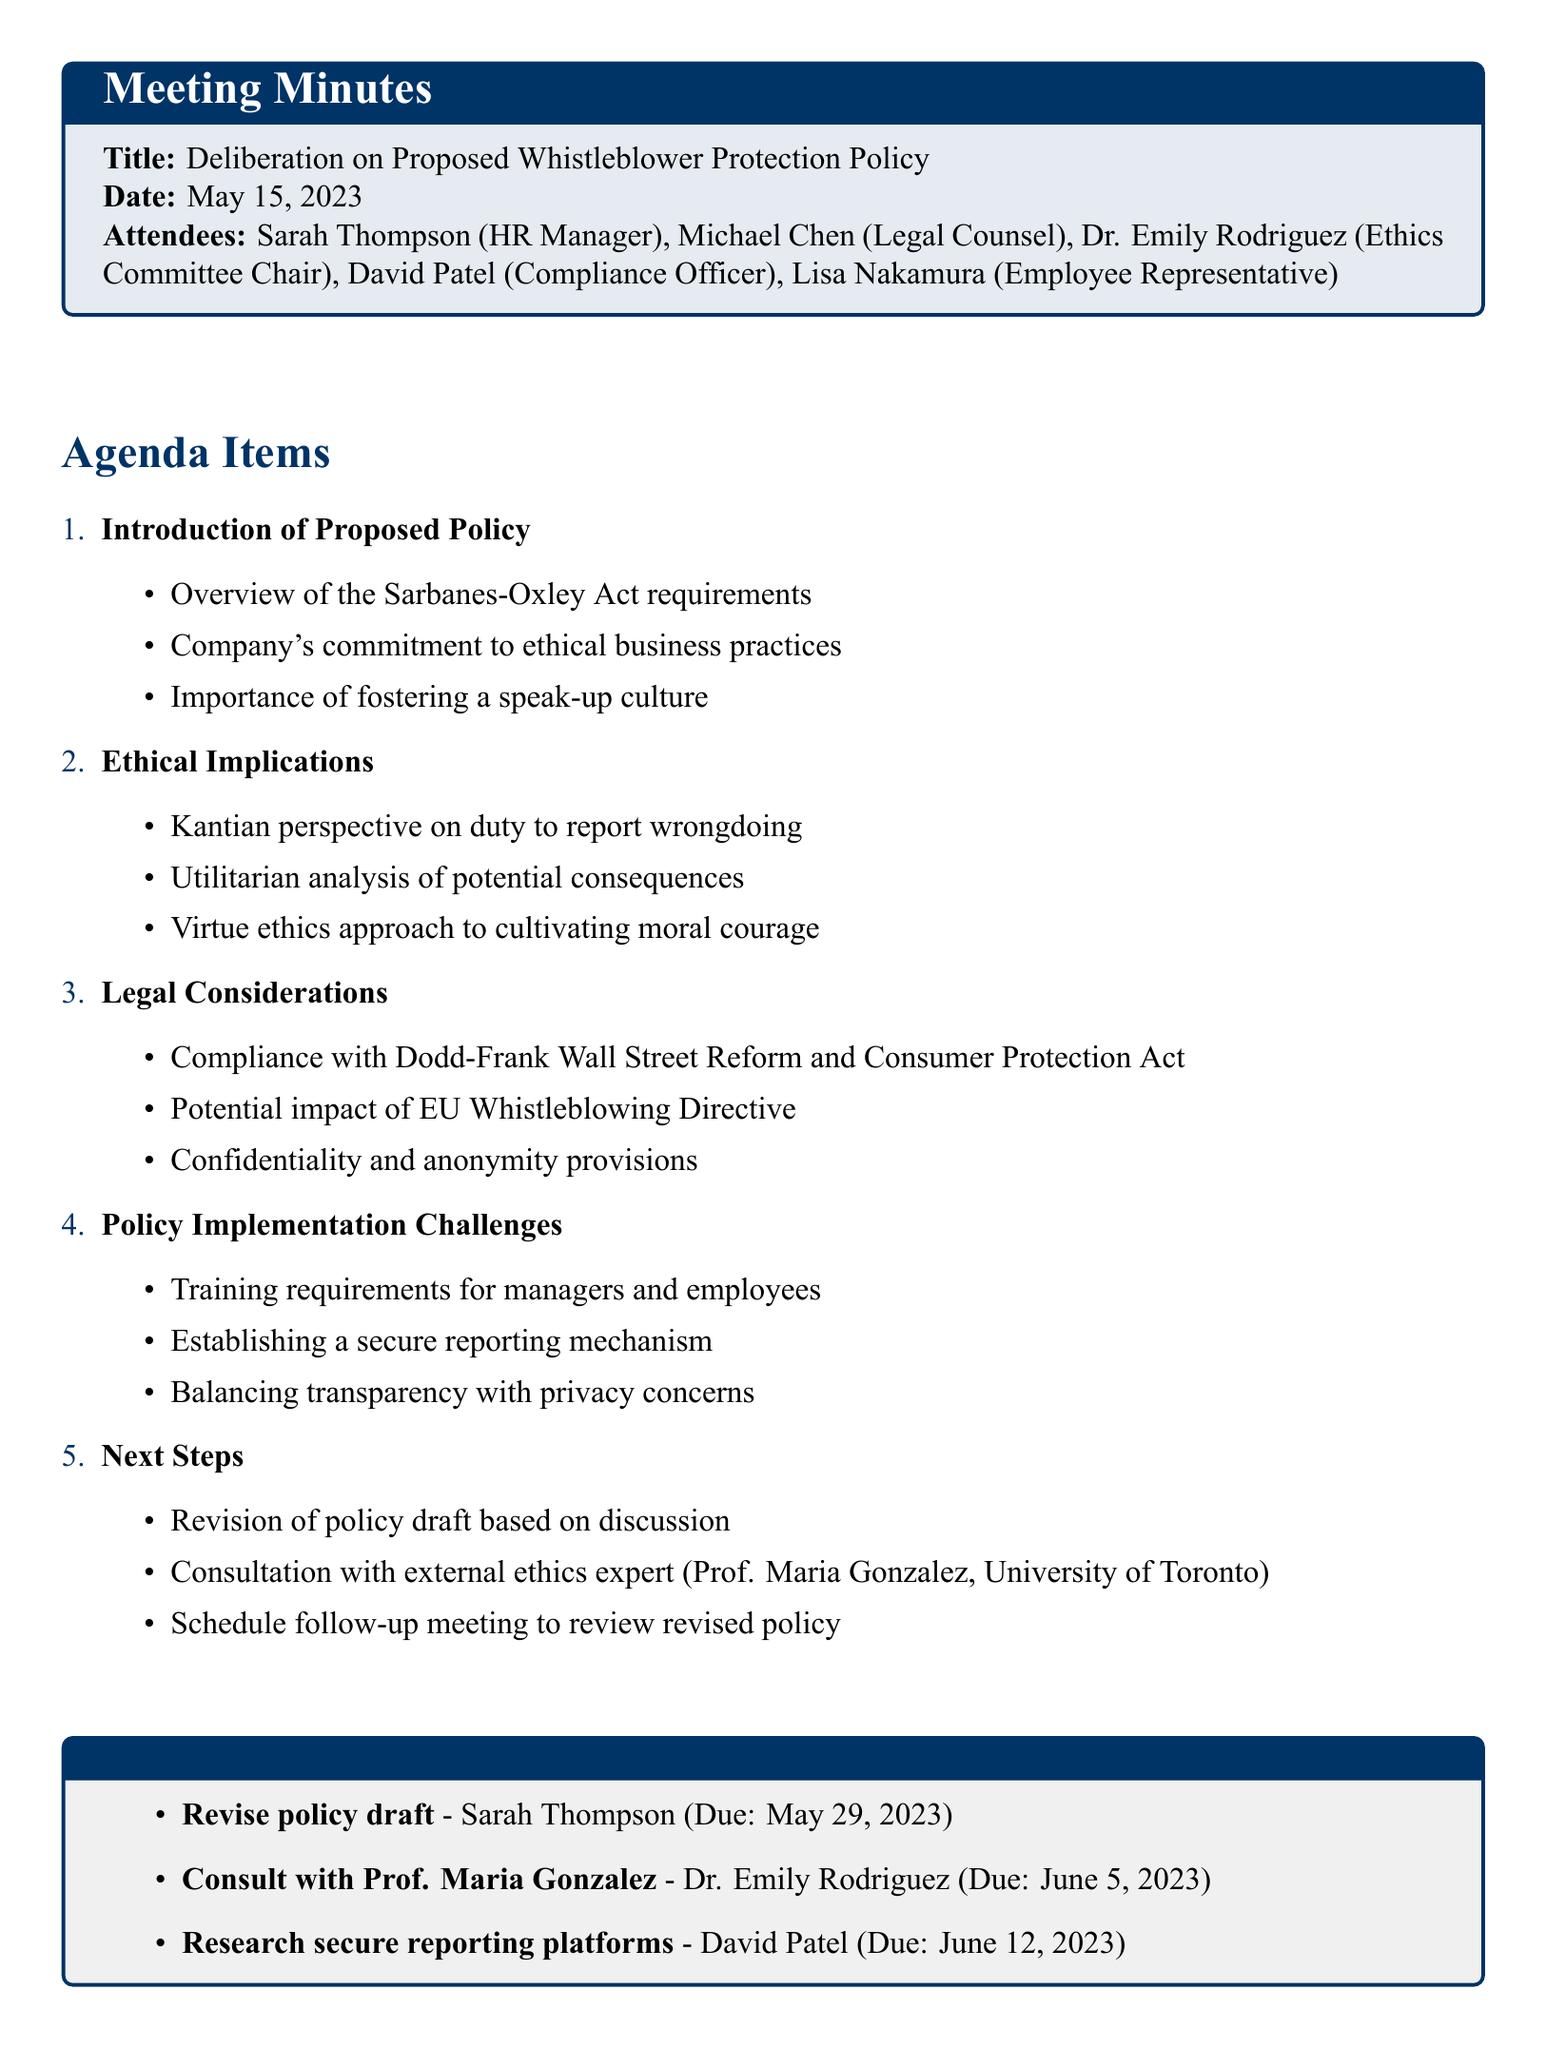what is the date of the meeting? The date of the meeting is explicitly noted in the document as "May 15, 2023".
Answer: May 15, 2023 who is the HR Manager present at the meeting? The document lists the attendees, including the HR Manager's name, which is "Sarah Thompson".
Answer: Sarah Thompson what act is referenced as a requirement for the proposed policy? The overview of the proposed policy mentions the "Sarbanes-Oxley Act requirements".
Answer: Sarbanes-Oxley Act which ethical perspective emphasizes the duty to report wrongdoing? The section on ethical implications includes a point specifically highlighting the "Kantian perspective".
Answer: Kantian perspective what is one of the action items assigned to Dr. Emily Rodriguez? The action items section specifies that Dr. Emily Rodriguez is tasked with consulting "Prof. Maria Gonzalez".
Answer: Consult with Prof. Maria Gonzalez what is one challenge associated with policy implementation mentioned? The document outlines several challenges, including "Establishing a secure reporting mechanism".
Answer: Establishing a secure reporting mechanism how many people attended the meeting? The list of attendees in the document indicates five individuals were present.
Answer: Five what is scheduled to happen after the consultation with Professor Maria Gonzalez? The next steps indicate a "follow-up meeting to review revised policy" is planned after the consultation.
Answer: Schedule follow-up meeting to review revised policy 